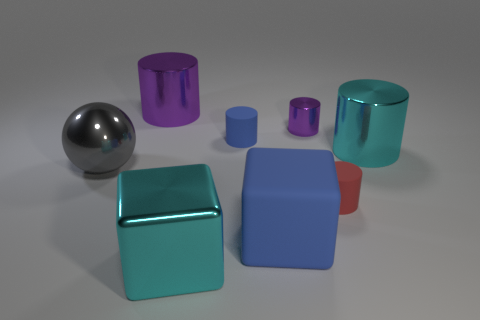Subtract all cyan cylinders. How many cylinders are left? 4 Subtract all brown cylinders. Subtract all blue cubes. How many cylinders are left? 5 Add 1 purple shiny things. How many objects exist? 9 Subtract all spheres. How many objects are left? 7 Subtract all large cyan blocks. Subtract all purple objects. How many objects are left? 5 Add 1 large metal cylinders. How many large metal cylinders are left? 3 Add 3 cyan things. How many cyan things exist? 5 Subtract 0 yellow cylinders. How many objects are left? 8 